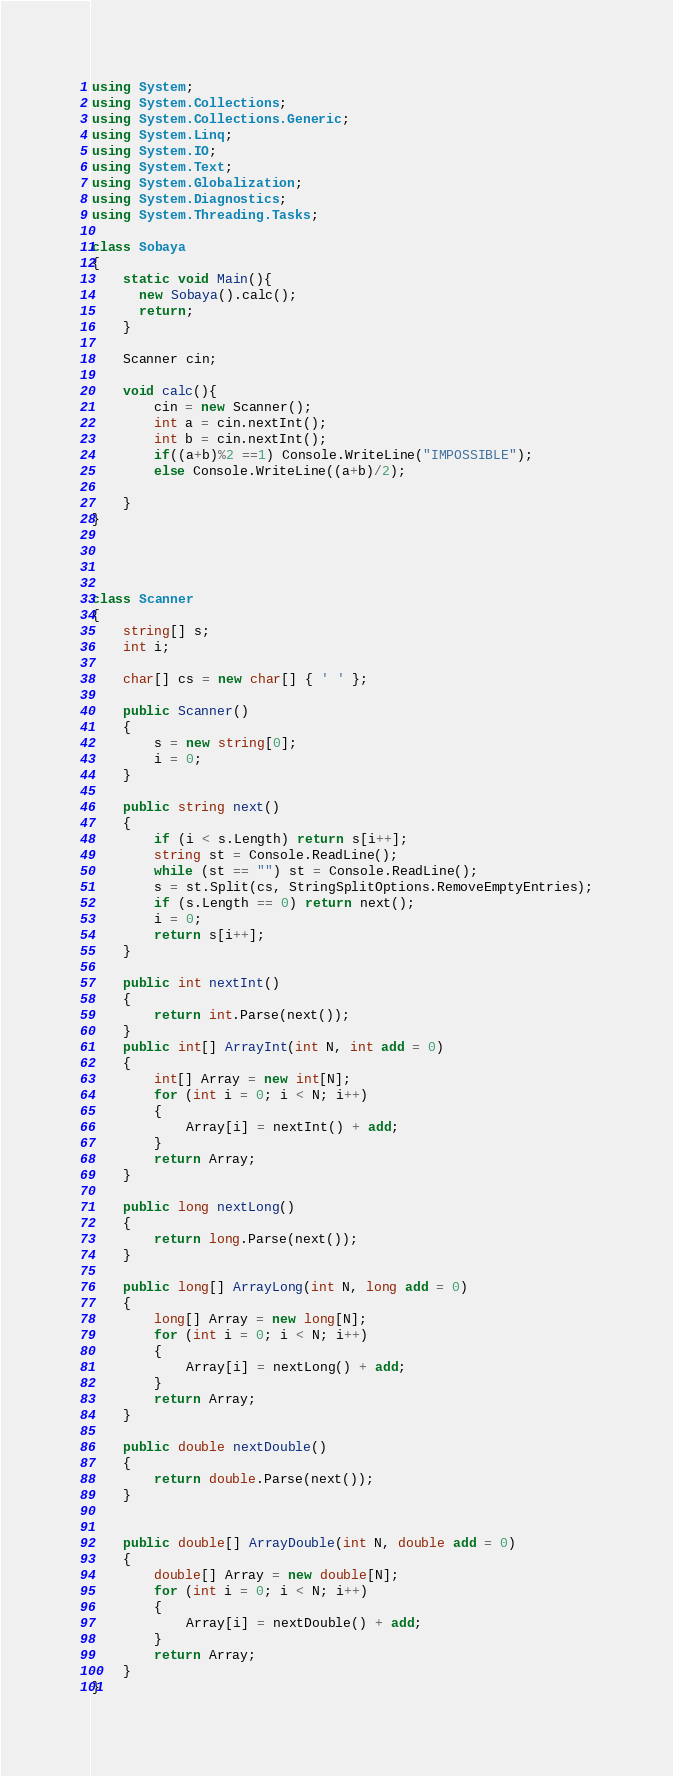<code> <loc_0><loc_0><loc_500><loc_500><_C#_>using System;
using System.Collections;
using System.Collections.Generic;
using System.Linq;
using System.IO;
using System.Text;
using System.Globalization;
using System.Diagnostics;
using System.Threading.Tasks;

class Sobaya
{
    static void Main(){
      new Sobaya().calc();
      return;
    }
      
    Scanner cin;
    
    void calc(){
        cin = new Scanner();
        int a = cin.nextInt();
        int b = cin.nextInt();
        if((a+b)%2 ==1) Console.WriteLine("IMPOSSIBLE");
        else Console.WriteLine((a+b)/2);

    }
}




class Scanner
{
    string[] s;
    int i;
 
    char[] cs = new char[] { ' ' };
 
    public Scanner()
    {
        s = new string[0];
        i = 0;
    }
 
    public string next()
    {
        if (i < s.Length) return s[i++];
        string st = Console.ReadLine();
        while (st == "") st = Console.ReadLine();
        s = st.Split(cs, StringSplitOptions.RemoveEmptyEntries);
        if (s.Length == 0) return next();
        i = 0;
        return s[i++];
    }
 
    public int nextInt()
    {
        return int.Parse(next());
    }
    public int[] ArrayInt(int N, int add = 0)
    {
        int[] Array = new int[N];
        for (int i = 0; i < N; i++)
        {
            Array[i] = nextInt() + add;
        }
        return Array;
    }
 
    public long nextLong()
    {
        return long.Parse(next());
    }
 
    public long[] ArrayLong(int N, long add = 0)
    {
        long[] Array = new long[N];
        for (int i = 0; i < N; i++)
        {
            Array[i] = nextLong() + add;
        }
        return Array;
    }
 
    public double nextDouble()
    {
        return double.Parse(next());
    }
 
 
    public double[] ArrayDouble(int N, double add = 0)
    {
        double[] Array = new double[N];
        for (int i = 0; i < N; i++)
        {
            Array[i] = nextDouble() + add;
        }
        return Array;
    }
}
</code> 